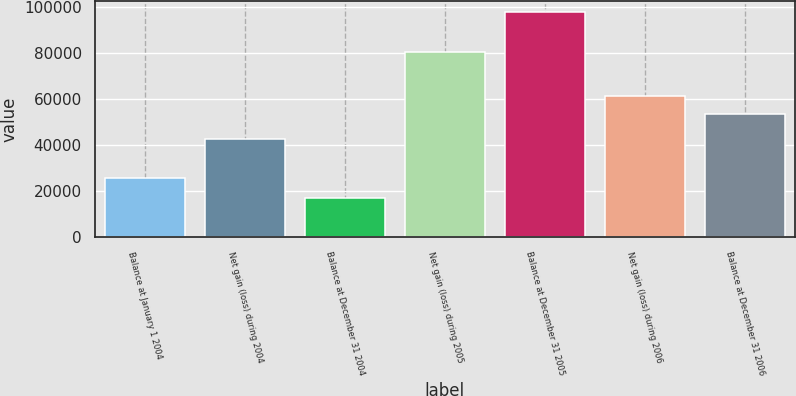<chart> <loc_0><loc_0><loc_500><loc_500><bar_chart><fcel>Balance at January 1 2004<fcel>Net gain (loss) during 2004<fcel>Balance at December 31 2004<fcel>Net gain (loss) during 2005<fcel>Balance at December 31 2005<fcel>Net gain (loss) during 2006<fcel>Balance at December 31 2006<nl><fcel>25653<fcel>42862<fcel>17209<fcel>80721<fcel>97930<fcel>61646.1<fcel>53574<nl></chart> 